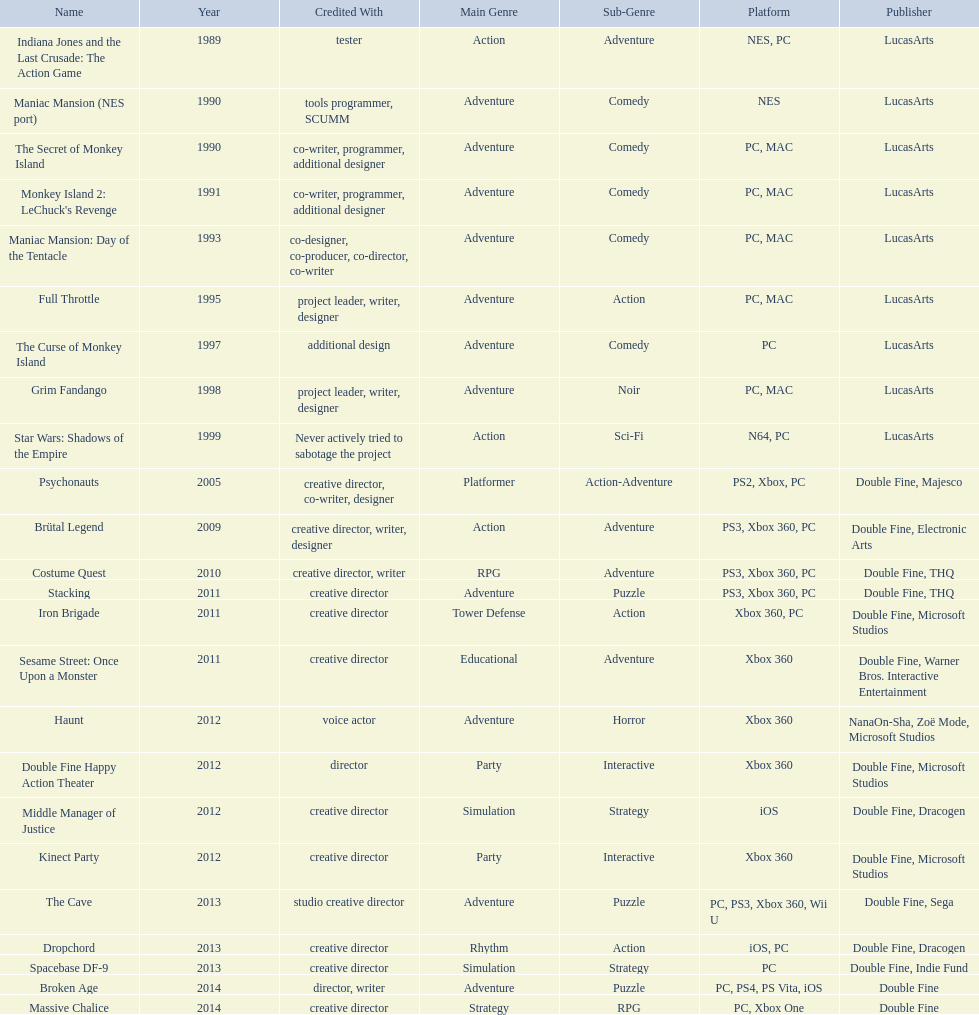What game name has tim schafer been involved with? Indiana Jones and the Last Crusade: The Action Game, Maniac Mansion (NES port), The Secret of Monkey Island, Monkey Island 2: LeChuck's Revenge, Maniac Mansion: Day of the Tentacle, Full Throttle, The Curse of Monkey Island, Grim Fandango, Star Wars: Shadows of the Empire, Psychonauts, Brütal Legend, Costume Quest, Stacking, Iron Brigade, Sesame Street: Once Upon a Monster, Haunt, Double Fine Happy Action Theater, Middle Manager of Justice, Kinect Party, The Cave, Dropchord, Spacebase DF-9, Broken Age, Massive Chalice. Which game has credit with just creative director? Creative director, creative director, creative director, creative director, creative director, creative director, creative director, creative director. Which games have the above and warner bros. interactive entertainment as publisher? Sesame Street: Once Upon a Monster. 